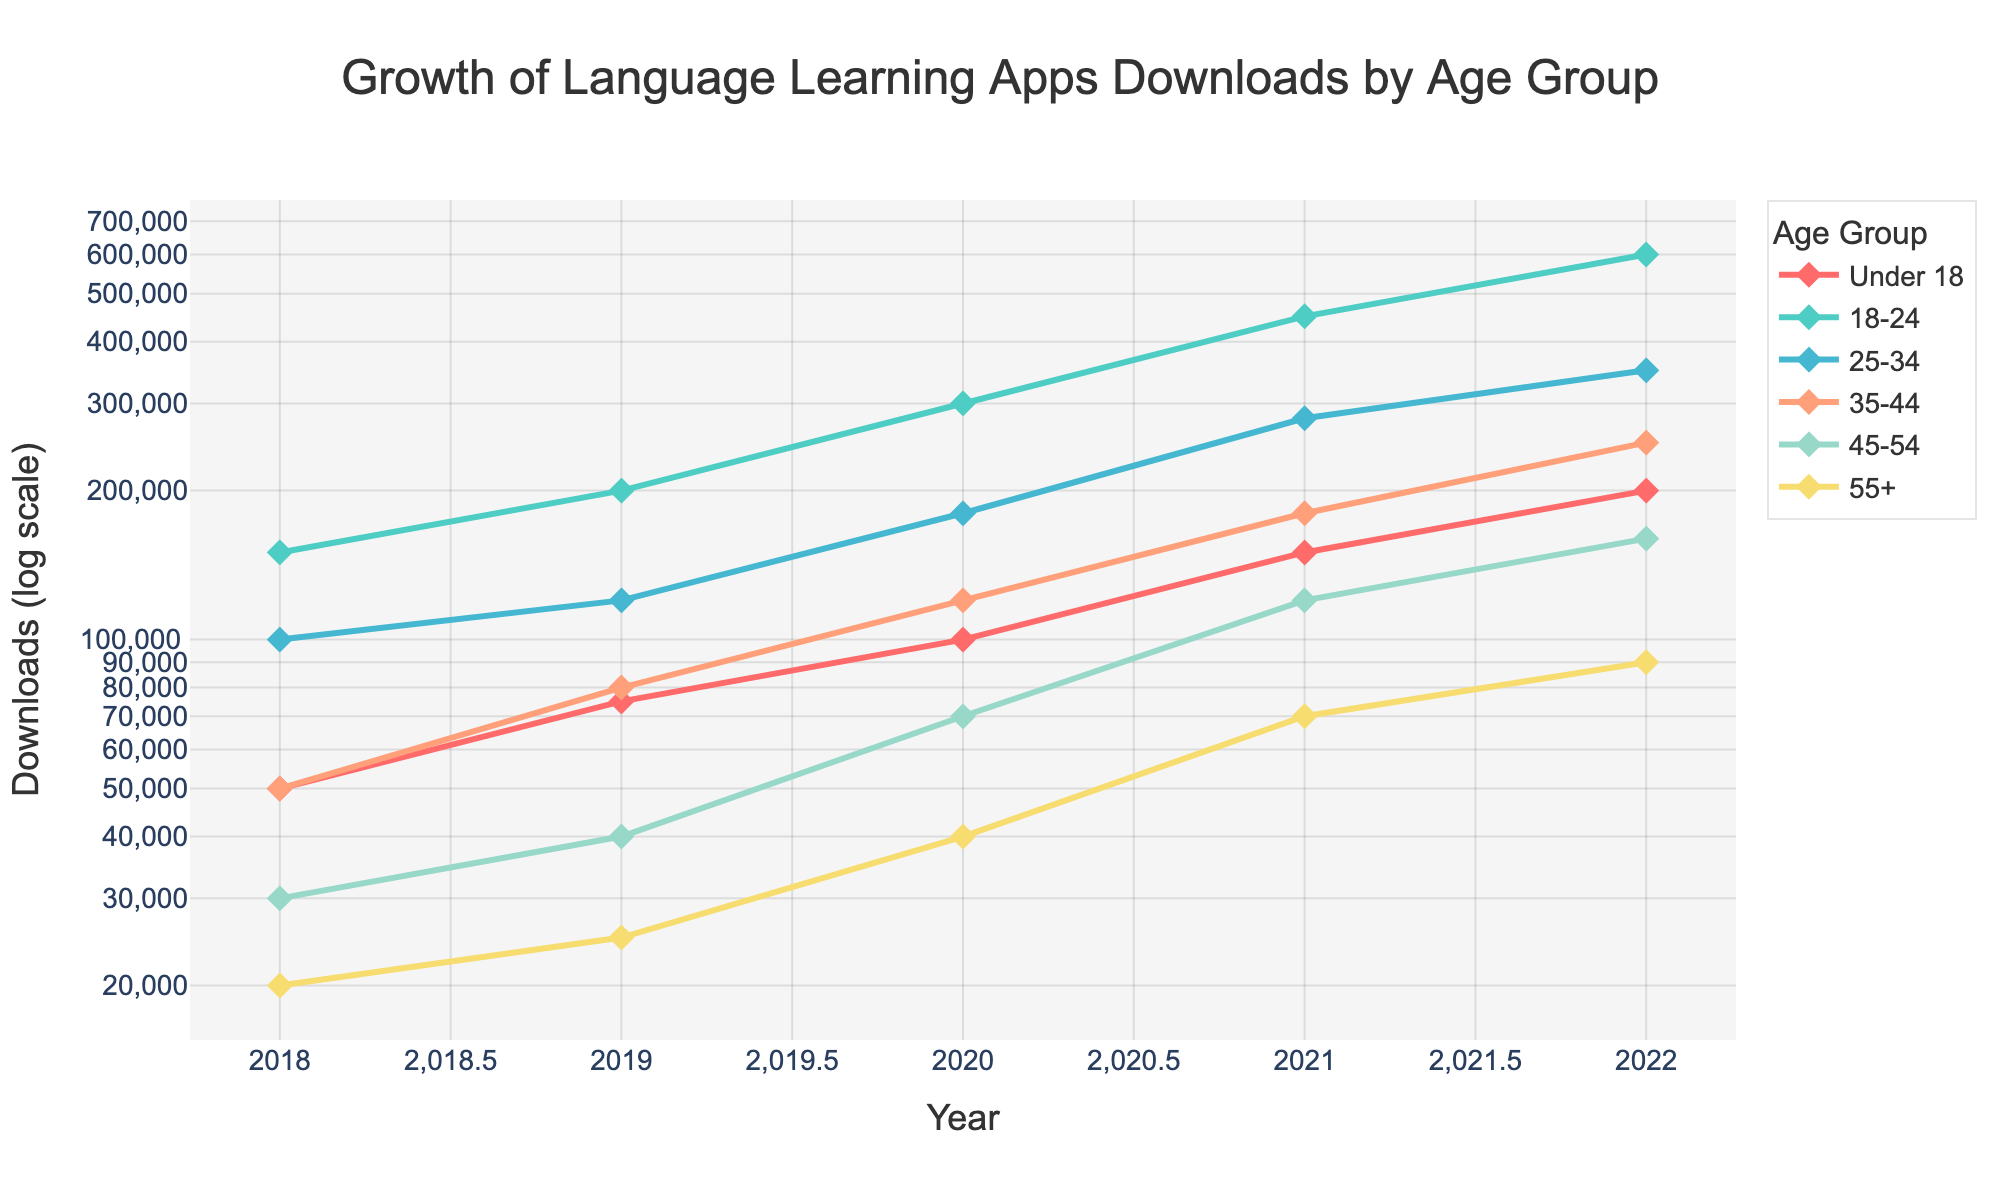How many age groups are displayed in the plot? The plot includes lines for different age groups; count the distinct lines or legend entries corresponding to each age group.
Answer: 6 What is the title of the figure? Identify the main heading or title text displayed at the top center of the figure.
Answer: Growth of Language Learning Apps Downloads by Age Group What type of scale is used on the y-axis? Observe the labeling and numerical representation of the y-axis, noting that it follows a logarithmic pattern.
Answer: Log scale Which age group had the highest number of downloads in 2022? Locate the 2022 data points and identify the age group with the highest y-axis value.
Answer: 18-24 By how much did the downloads increase for the 25-34 age group from 2018 to 2022? Identify the download numbers for 25-34 in 2018 and 2022, then calculate the difference. 350,000 - 100,000 = 250,000
Answer: 250,000 Which age group shows the most consistent growth trend from 2018 to 2022? Evaluate the overall shape and slope of the lines representing each age group and choose the one that shows a steady increase without sudden changes.
Answer: 18-24 What is the approximate number of downloads for the 45-54 age group in 2021? Identify the data point for the 45-54 age group in 2021 and read the corresponding y-axis value.
Answer: 120,000 Compare the downloads of the under 18 and 55+ age groups in 2020. Which group had more downloads and by how much? Find the 2020 data points for under 18 and 55+, then subtract the smaller number from the larger one to find the difference. 100,000 - 40,000 = 60,000
Answer: Under 18, 60,000 What general trend is visible in the downloads of language learning apps across all age groups from 2018 to 2022? Summarize the overall movement observed in the lines representing different age groups, noting whether they generally move upward, downward, or vary.
Answer: Increasing trend 